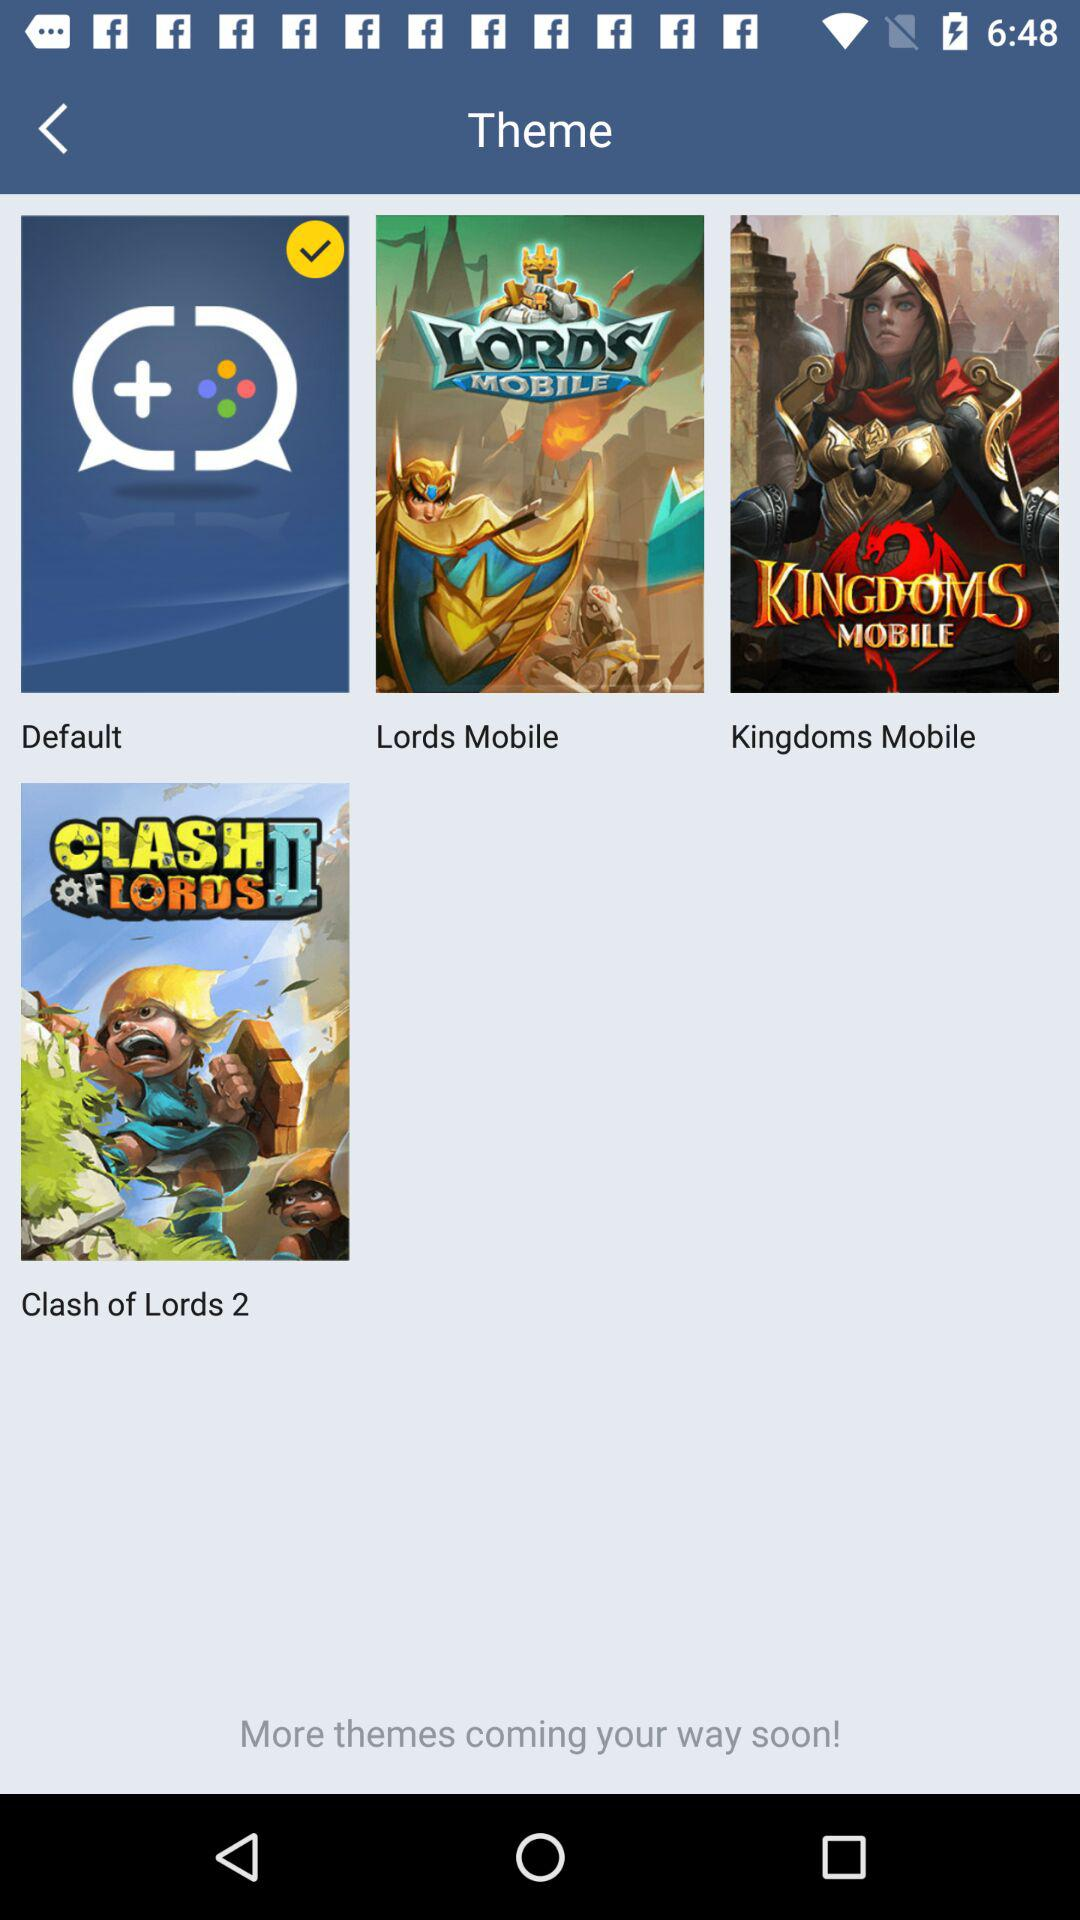Which are the different theme options? The different theme options are "Default", "Lords Mobile", "Kingdoms Mobile" and "Clash of Lords 2". 